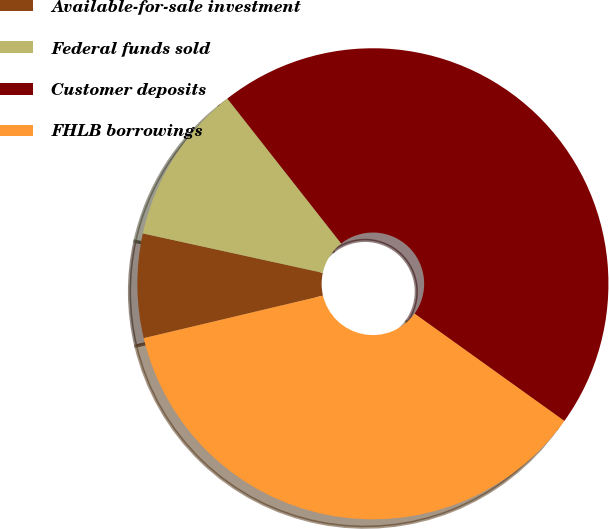<chart> <loc_0><loc_0><loc_500><loc_500><pie_chart><fcel>Available-for-sale investment<fcel>Federal funds sold<fcel>Customer deposits<fcel>FHLB borrowings<nl><fcel>7.14%<fcel>10.97%<fcel>45.49%<fcel>36.4%<nl></chart> 